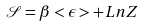<formula> <loc_0><loc_0><loc_500><loc_500>\mathcal { S } = \beta < \epsilon > + L n Z</formula> 